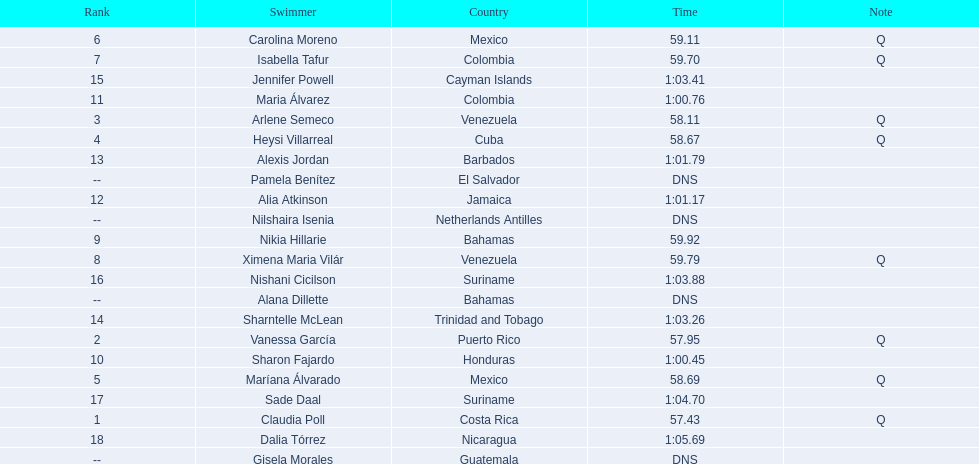Where were the top eight finishers from? Costa Rica, Puerto Rico, Venezuela, Cuba, Mexico, Mexico, Colombia, Venezuela. Which of the top eight were from cuba? Heysi Villarreal. 